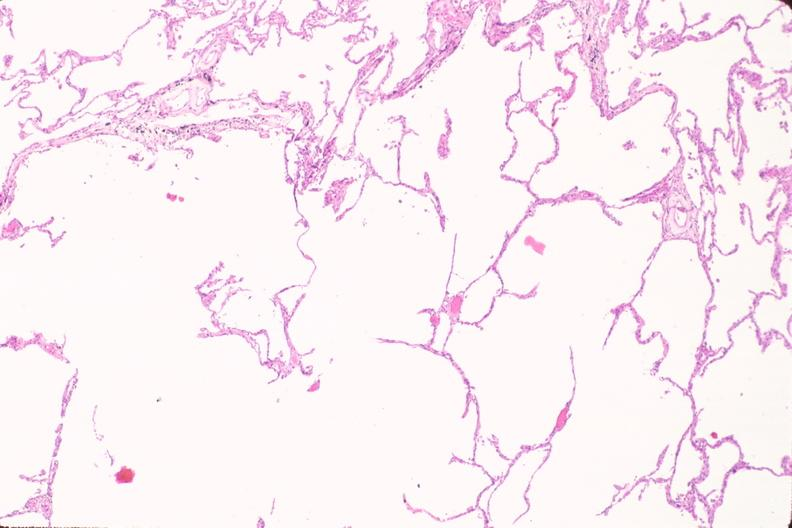what is present?
Answer the question using a single word or phrase. Respiratory 